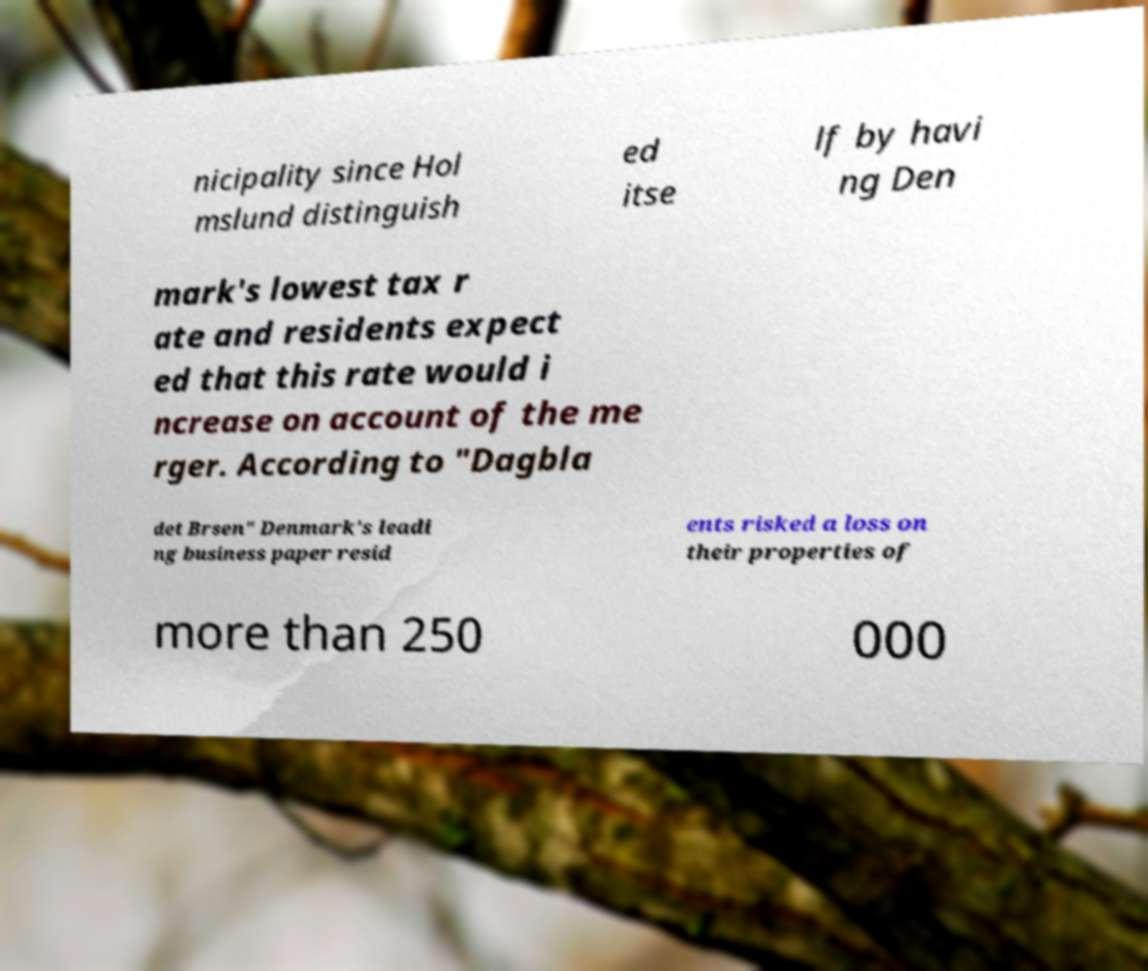For documentation purposes, I need the text within this image transcribed. Could you provide that? nicipality since Hol mslund distinguish ed itse lf by havi ng Den mark's lowest tax r ate and residents expect ed that this rate would i ncrease on account of the me rger. According to "Dagbla det Brsen" Denmark's leadi ng business paper resid ents risked a loss on their properties of more than 250 000 